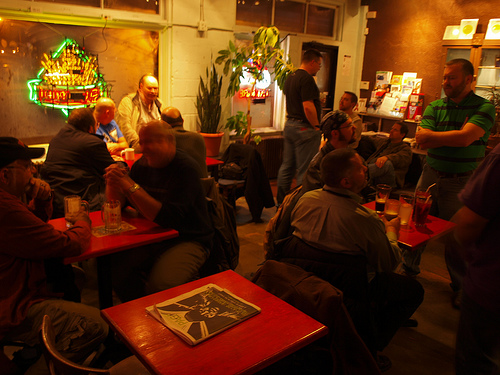<image>
Is there a shirt on the man? No. The shirt is not positioned on the man. They may be near each other, but the shirt is not supported by or resting on top of the man. 